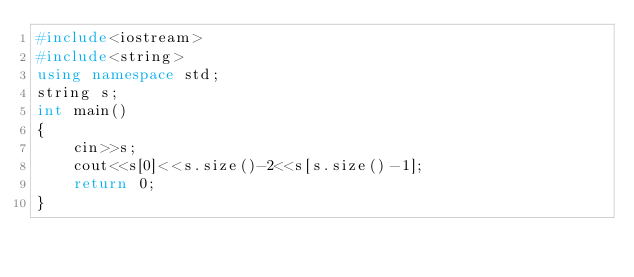Convert code to text. <code><loc_0><loc_0><loc_500><loc_500><_C++_>#include<iostream>
#include<string>
using namespace std;
string s;
int main()
{
	cin>>s;
	cout<<s[0]<<s.size()-2<<s[s.size()-1];
	return 0;
}</code> 